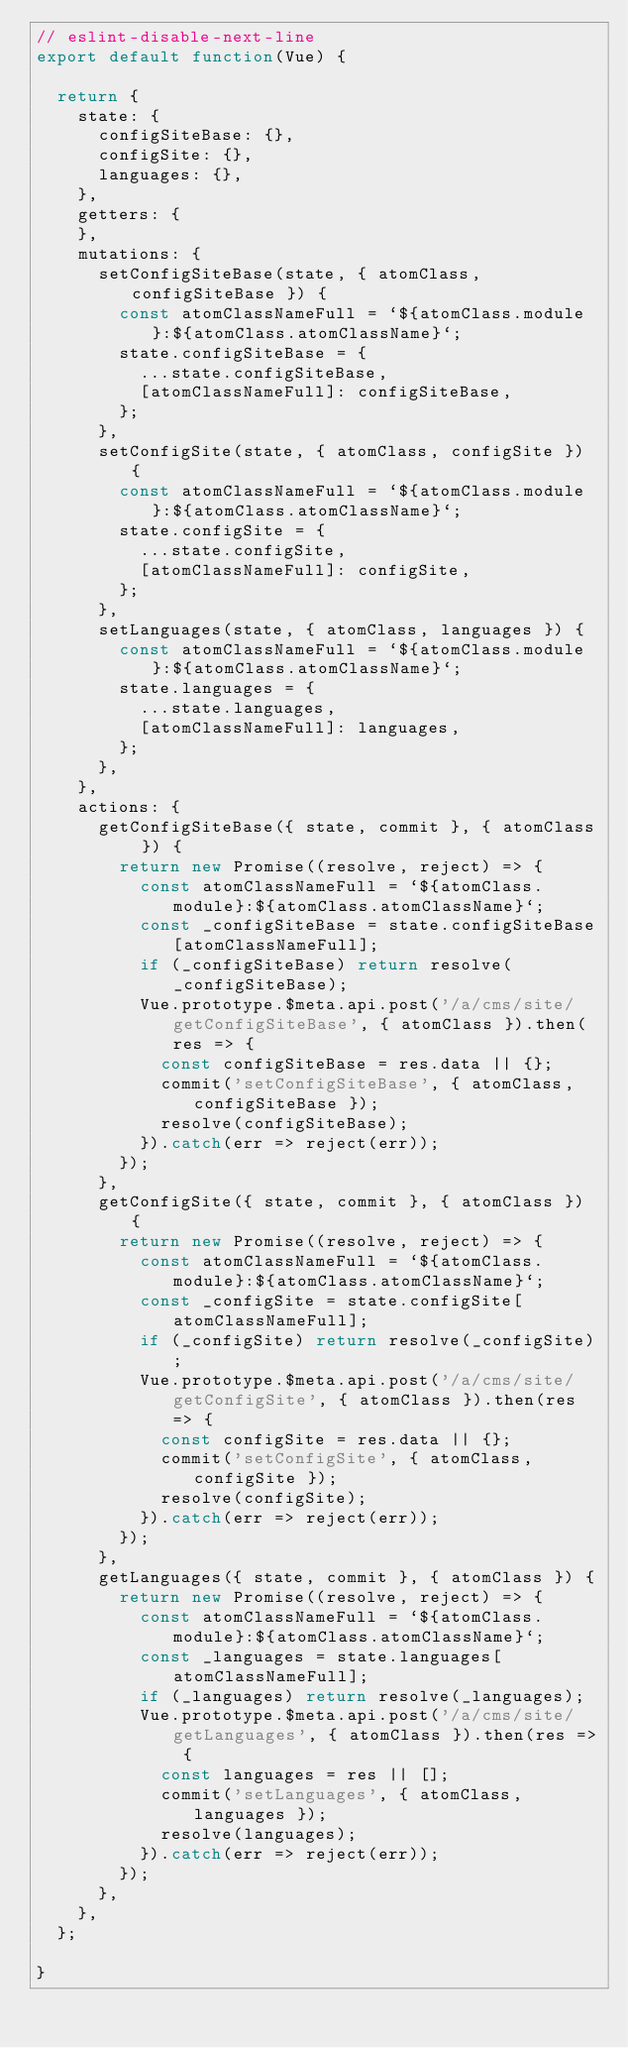Convert code to text. <code><loc_0><loc_0><loc_500><loc_500><_JavaScript_>// eslint-disable-next-line
export default function(Vue) {

  return {
    state: {
      configSiteBase: {},
      configSite: {},
      languages: {},
    },
    getters: {
    },
    mutations: {
      setConfigSiteBase(state, { atomClass, configSiteBase }) {
        const atomClassNameFull = `${atomClass.module}:${atomClass.atomClassName}`;
        state.configSiteBase = {
          ...state.configSiteBase,
          [atomClassNameFull]: configSiteBase,
        };
      },
      setConfigSite(state, { atomClass, configSite }) {
        const atomClassNameFull = `${atomClass.module}:${atomClass.atomClassName}`;
        state.configSite = {
          ...state.configSite,
          [atomClassNameFull]: configSite,
        };
      },
      setLanguages(state, { atomClass, languages }) {
        const atomClassNameFull = `${atomClass.module}:${atomClass.atomClassName}`;
        state.languages = {
          ...state.languages,
          [atomClassNameFull]: languages,
        };
      },
    },
    actions: {
      getConfigSiteBase({ state, commit }, { atomClass }) {
        return new Promise((resolve, reject) => {
          const atomClassNameFull = `${atomClass.module}:${atomClass.atomClassName}`;
          const _configSiteBase = state.configSiteBase[atomClassNameFull];
          if (_configSiteBase) return resolve(_configSiteBase);
          Vue.prototype.$meta.api.post('/a/cms/site/getConfigSiteBase', { atomClass }).then(res => {
            const configSiteBase = res.data || {};
            commit('setConfigSiteBase', { atomClass, configSiteBase });
            resolve(configSiteBase);
          }).catch(err => reject(err));
        });
      },
      getConfigSite({ state, commit }, { atomClass }) {
        return new Promise((resolve, reject) => {
          const atomClassNameFull = `${atomClass.module}:${atomClass.atomClassName}`;
          const _configSite = state.configSite[atomClassNameFull];
          if (_configSite) return resolve(_configSite);
          Vue.prototype.$meta.api.post('/a/cms/site/getConfigSite', { atomClass }).then(res => {
            const configSite = res.data || {};
            commit('setConfigSite', { atomClass, configSite });
            resolve(configSite);
          }).catch(err => reject(err));
        });
      },
      getLanguages({ state, commit }, { atomClass }) {
        return new Promise((resolve, reject) => {
          const atomClassNameFull = `${atomClass.module}:${atomClass.atomClassName}`;
          const _languages = state.languages[atomClassNameFull];
          if (_languages) return resolve(_languages);
          Vue.prototype.$meta.api.post('/a/cms/site/getLanguages', { atomClass }).then(res => {
            const languages = res || [];
            commit('setLanguages', { atomClass, languages });
            resolve(languages);
          }).catch(err => reject(err));
        });
      },
    },
  };

}
</code> 